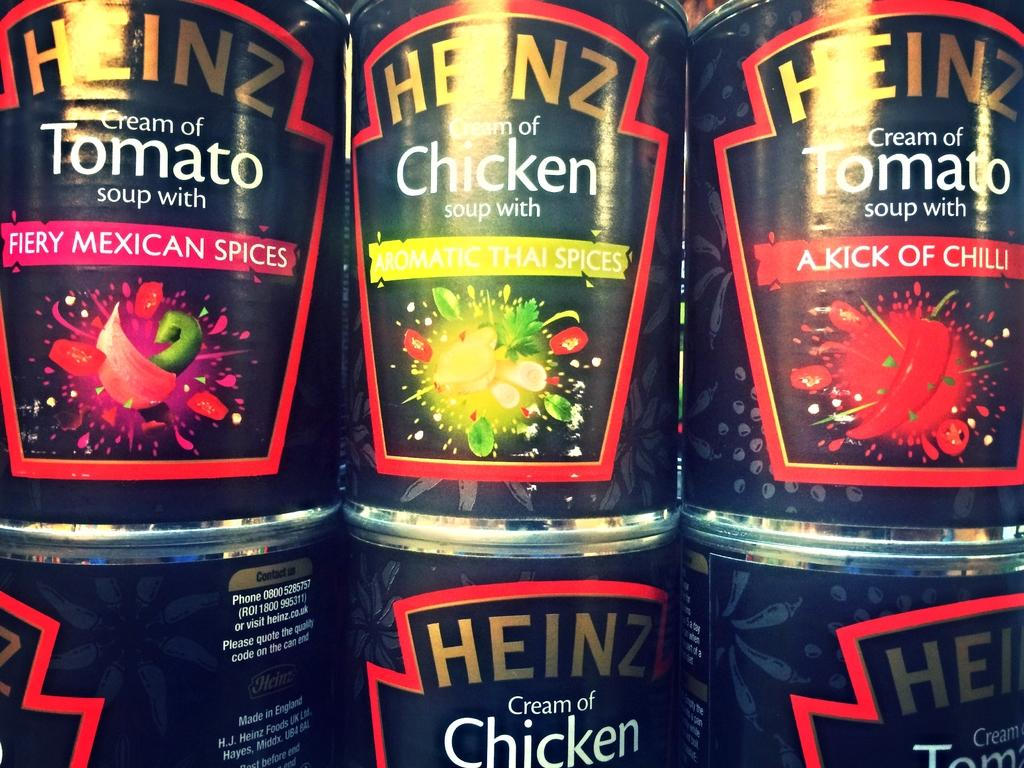What type of objects can be seen in the image? There are tins in the image. What country is the dog from, as seen in the image? There is no dog present in the image, so it is not possible to determine the country of origin for a dog. 